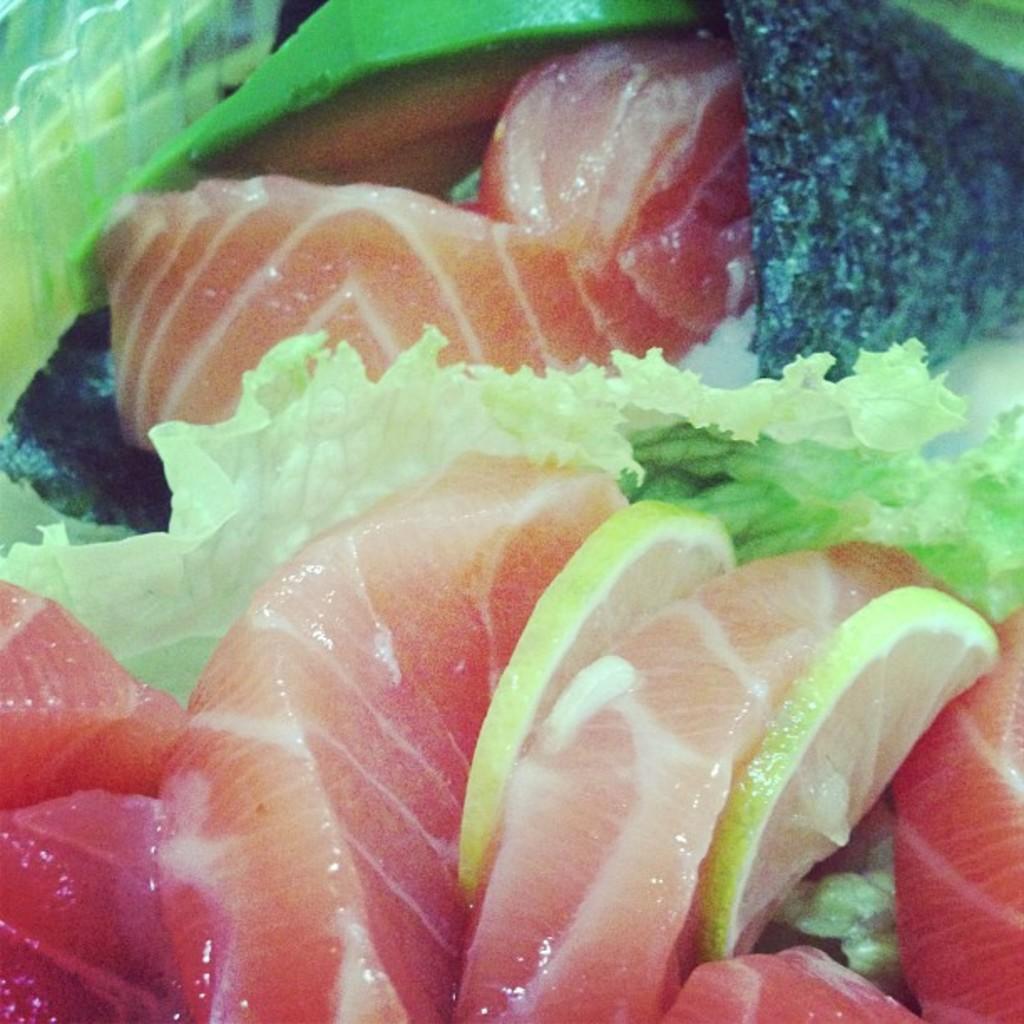Can you describe this image briefly? In this picture we can observe some food. There is some meat and lemon slices in this picture. 